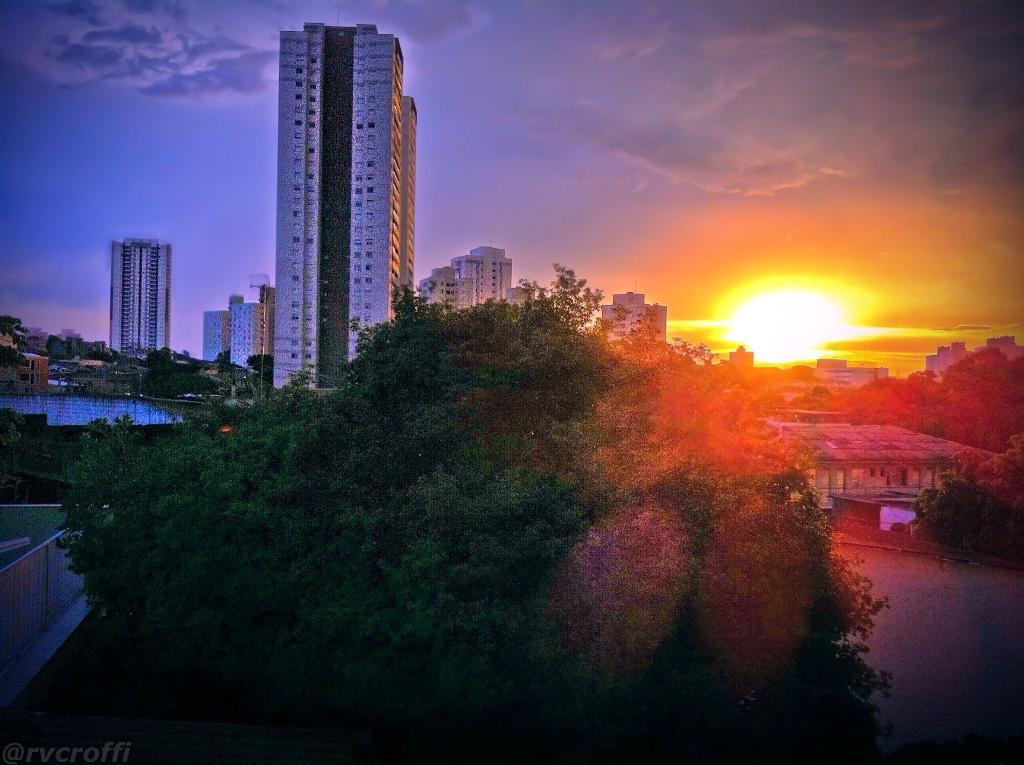What type of natural elements can be seen in the image? There are trees in the image. What type of man-made structures are present in the image? There are buildings in the image. What body of water is visible in the image? There is a lake in the image. What can be seen in the sky in the background of the image? There are clouds and the sun visible in the sky in the background of the image. Where is the robin perched in the image? There is no robin present in the image. What type of representative can be seen in the image? There is no representative present in the image. 